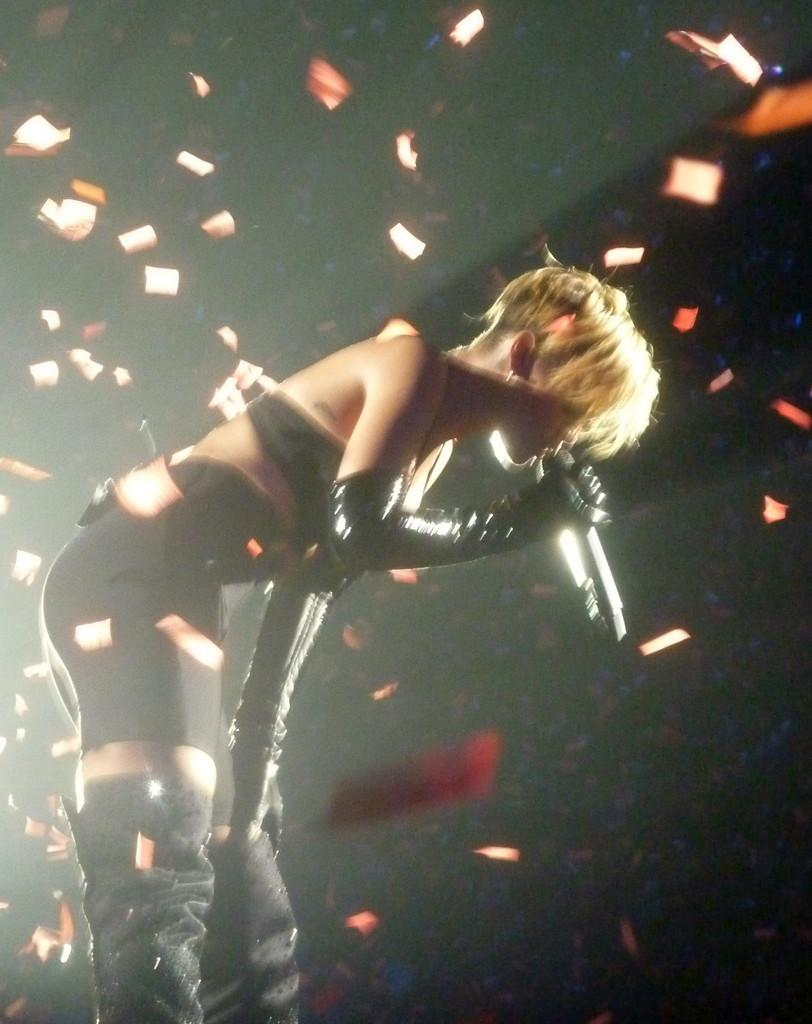What is the woman in the image doing? The woman is singing. What is the woman holding in her hand? The woman is holding a microphone in her hand. What is the woman wearing? The woman is wearing a black dress. Is the woman holding an umbrella in the image? No, the woman is not holding an umbrella in the image; she is holding a microphone. Is there any water visible in the image? No, there is no water visible in the image. 